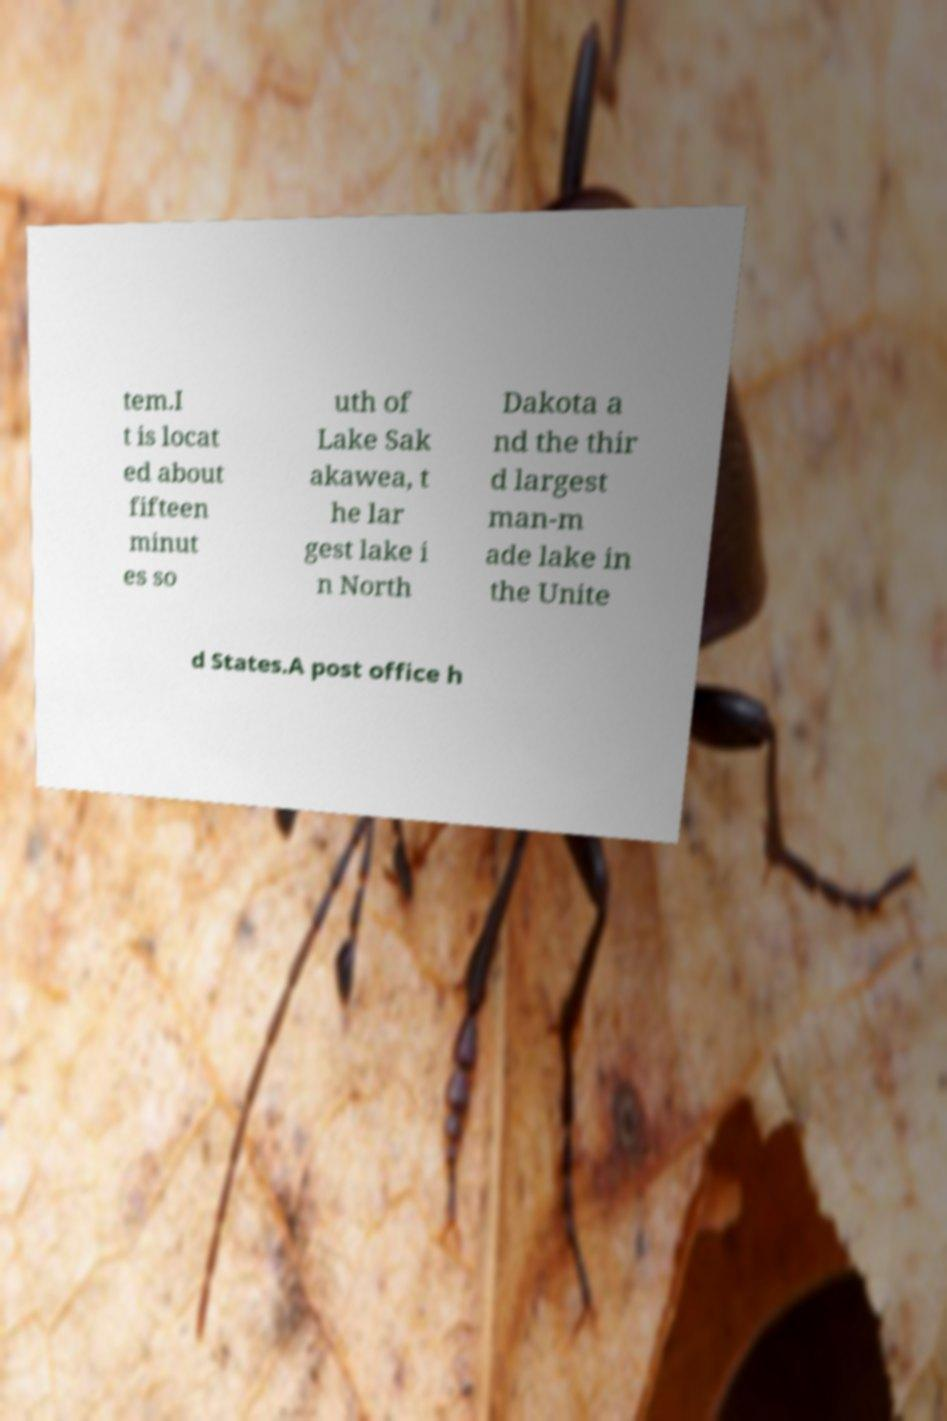Please identify and transcribe the text found in this image. tem.I t is locat ed about fifteen minut es so uth of Lake Sak akawea, t he lar gest lake i n North Dakota a nd the thir d largest man-m ade lake in the Unite d States.A post office h 